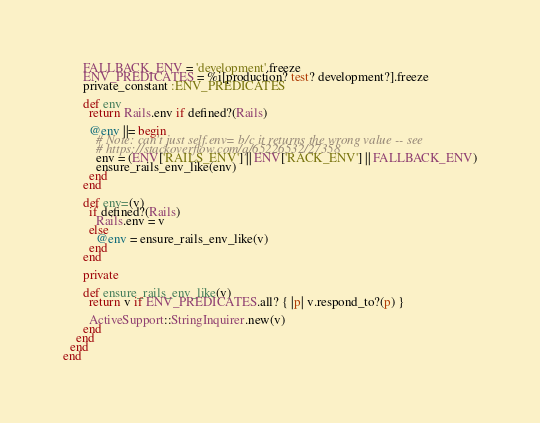<code> <loc_0><loc_0><loc_500><loc_500><_Ruby_>      FALLBACK_ENV = 'development'.freeze
      ENV_PREDICATES = %i[production? test? development?].freeze
      private_constant :ENV_PREDICATES

      def env
        return Rails.env if defined?(Rails)

        @env ||= begin
          # Note: can't just self.env= b/c it returns the wrong value -- see
          # https://stackoverflow.com/q/65226532/27358
          env = (ENV['RAILS_ENV'] || ENV['RACK_ENV'] || FALLBACK_ENV)
          ensure_rails_env_like(env)
        end
      end

      def env=(v)
        if defined?(Rails)
          Rails.env = v
        else
          @env = ensure_rails_env_like(v)
        end
      end

      private

      def ensure_rails_env_like(v)
        return v if ENV_PREDICATES.all? { |p| v.respond_to?(p) }

        ActiveSupport::StringInquirer.new(v)
      end
    end
  end
end
</code> 